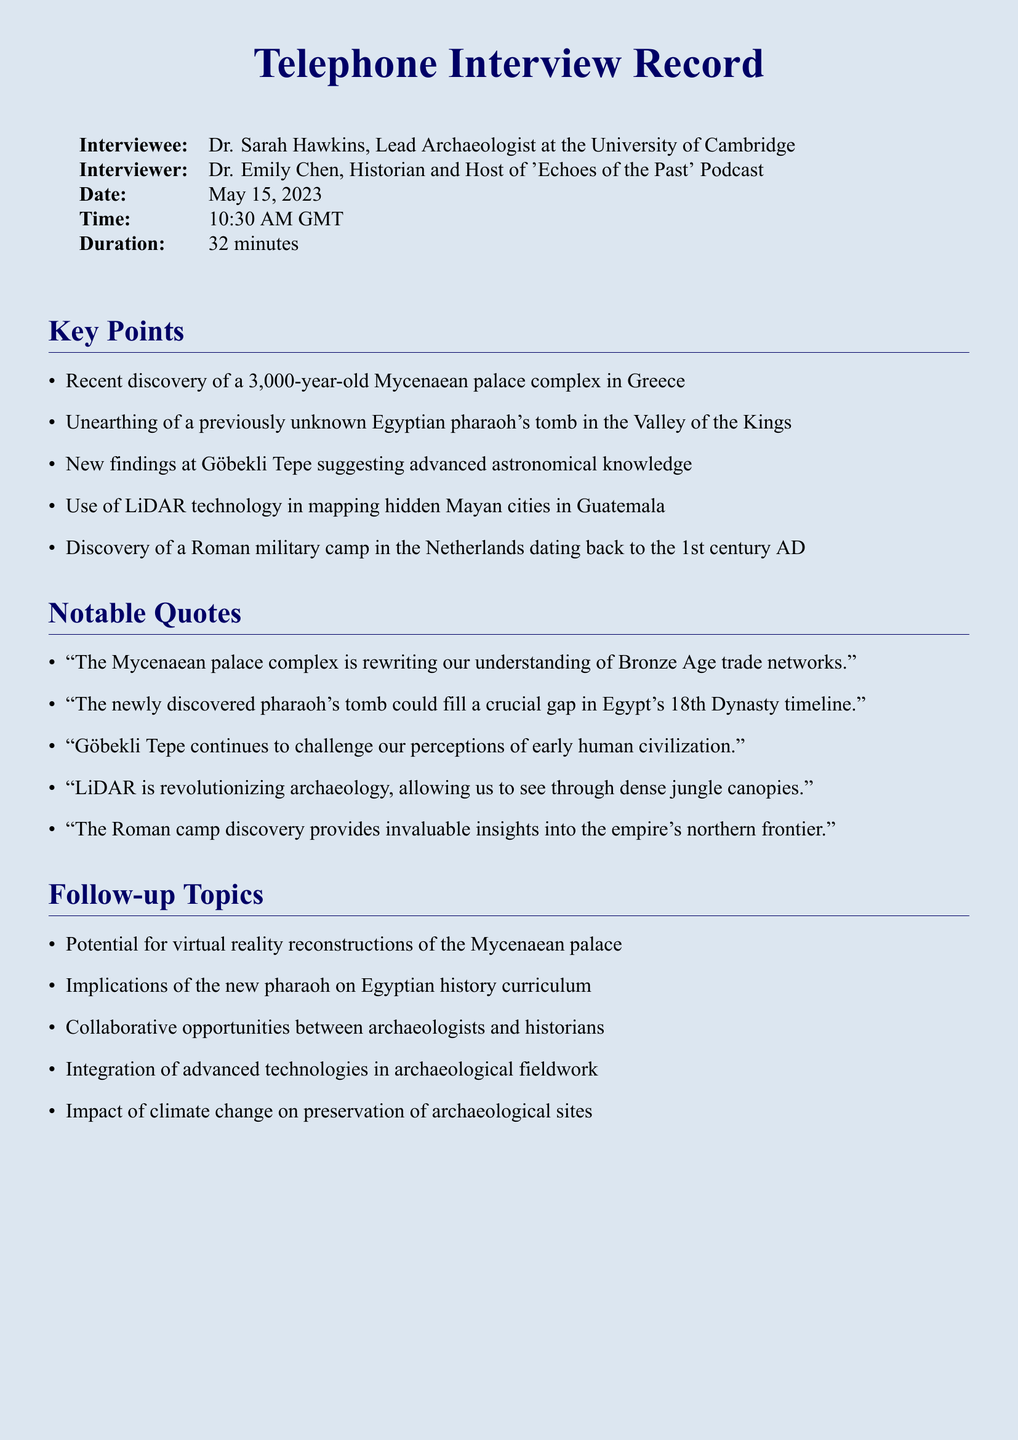What is the title of the interview? The title of the interview is found in the document's heading section.
Answer: Telephone Interview Record Who is the lead archaeologist interviewed? The document lists the interviewee's name and title.
Answer: Dr. Sarah Hawkins What significant discovery is mentioned relating to the Mycenaean civilization? The document highlights key points, including notable findings.
Answer: Mycenaean palace complex What technology is mentioned as revolutionizing archaeology? The notable quotes section discusses advancements in archaeology.
Answer: LiDAR In what year does the interview take place? The date provided in the document indicates when the interview occurred.
Answer: 2023 How long is the duration of the interview? The length of the interview is stated in the introductory table.
Answer: 32 minutes What civilization is associated with the newly discovered pharaoh's tomb? The document refers to the location of the tomb in the context of a civilization.
Answer: Egyptian What implication is discussed regarding the newly discovered pharaoh? The follow-up topics suggest areas impacted by the discovery.
Answer: Egyptian history curriculum Which archaeological site is noted for its advanced astronomical knowledge? The key points section includes details about specific archaeological findings.
Answer: Göbekli Tepe 